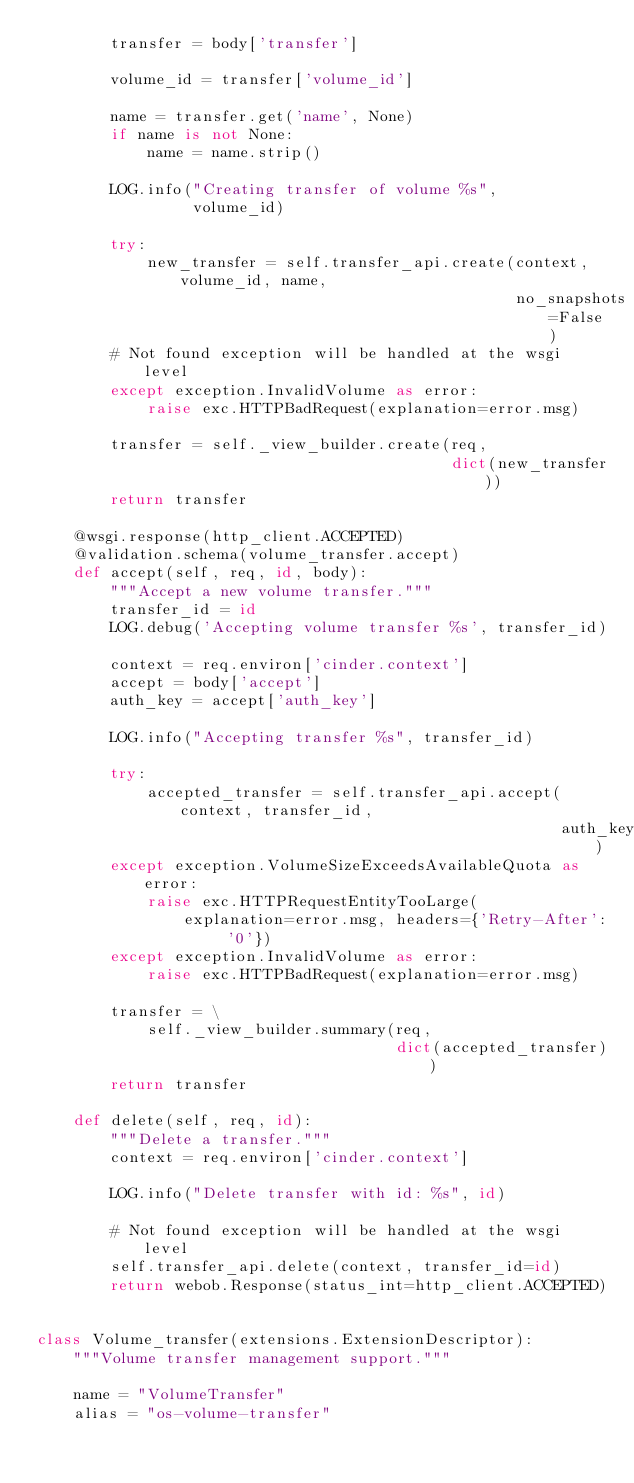Convert code to text. <code><loc_0><loc_0><loc_500><loc_500><_Python_>        transfer = body['transfer']

        volume_id = transfer['volume_id']

        name = transfer.get('name', None)
        if name is not None:
            name = name.strip()

        LOG.info("Creating transfer of volume %s",
                 volume_id)

        try:
            new_transfer = self.transfer_api.create(context, volume_id, name,
                                                    no_snapshots=False)
        # Not found exception will be handled at the wsgi level
        except exception.InvalidVolume as error:
            raise exc.HTTPBadRequest(explanation=error.msg)

        transfer = self._view_builder.create(req,
                                             dict(new_transfer))
        return transfer

    @wsgi.response(http_client.ACCEPTED)
    @validation.schema(volume_transfer.accept)
    def accept(self, req, id, body):
        """Accept a new volume transfer."""
        transfer_id = id
        LOG.debug('Accepting volume transfer %s', transfer_id)

        context = req.environ['cinder.context']
        accept = body['accept']
        auth_key = accept['auth_key']

        LOG.info("Accepting transfer %s", transfer_id)

        try:
            accepted_transfer = self.transfer_api.accept(context, transfer_id,
                                                         auth_key)
        except exception.VolumeSizeExceedsAvailableQuota as error:
            raise exc.HTTPRequestEntityTooLarge(
                explanation=error.msg, headers={'Retry-After': '0'})
        except exception.InvalidVolume as error:
            raise exc.HTTPBadRequest(explanation=error.msg)

        transfer = \
            self._view_builder.summary(req,
                                       dict(accepted_transfer))
        return transfer

    def delete(self, req, id):
        """Delete a transfer."""
        context = req.environ['cinder.context']

        LOG.info("Delete transfer with id: %s", id)

        # Not found exception will be handled at the wsgi level
        self.transfer_api.delete(context, transfer_id=id)
        return webob.Response(status_int=http_client.ACCEPTED)


class Volume_transfer(extensions.ExtensionDescriptor):
    """Volume transfer management support."""

    name = "VolumeTransfer"
    alias = "os-volume-transfer"</code> 